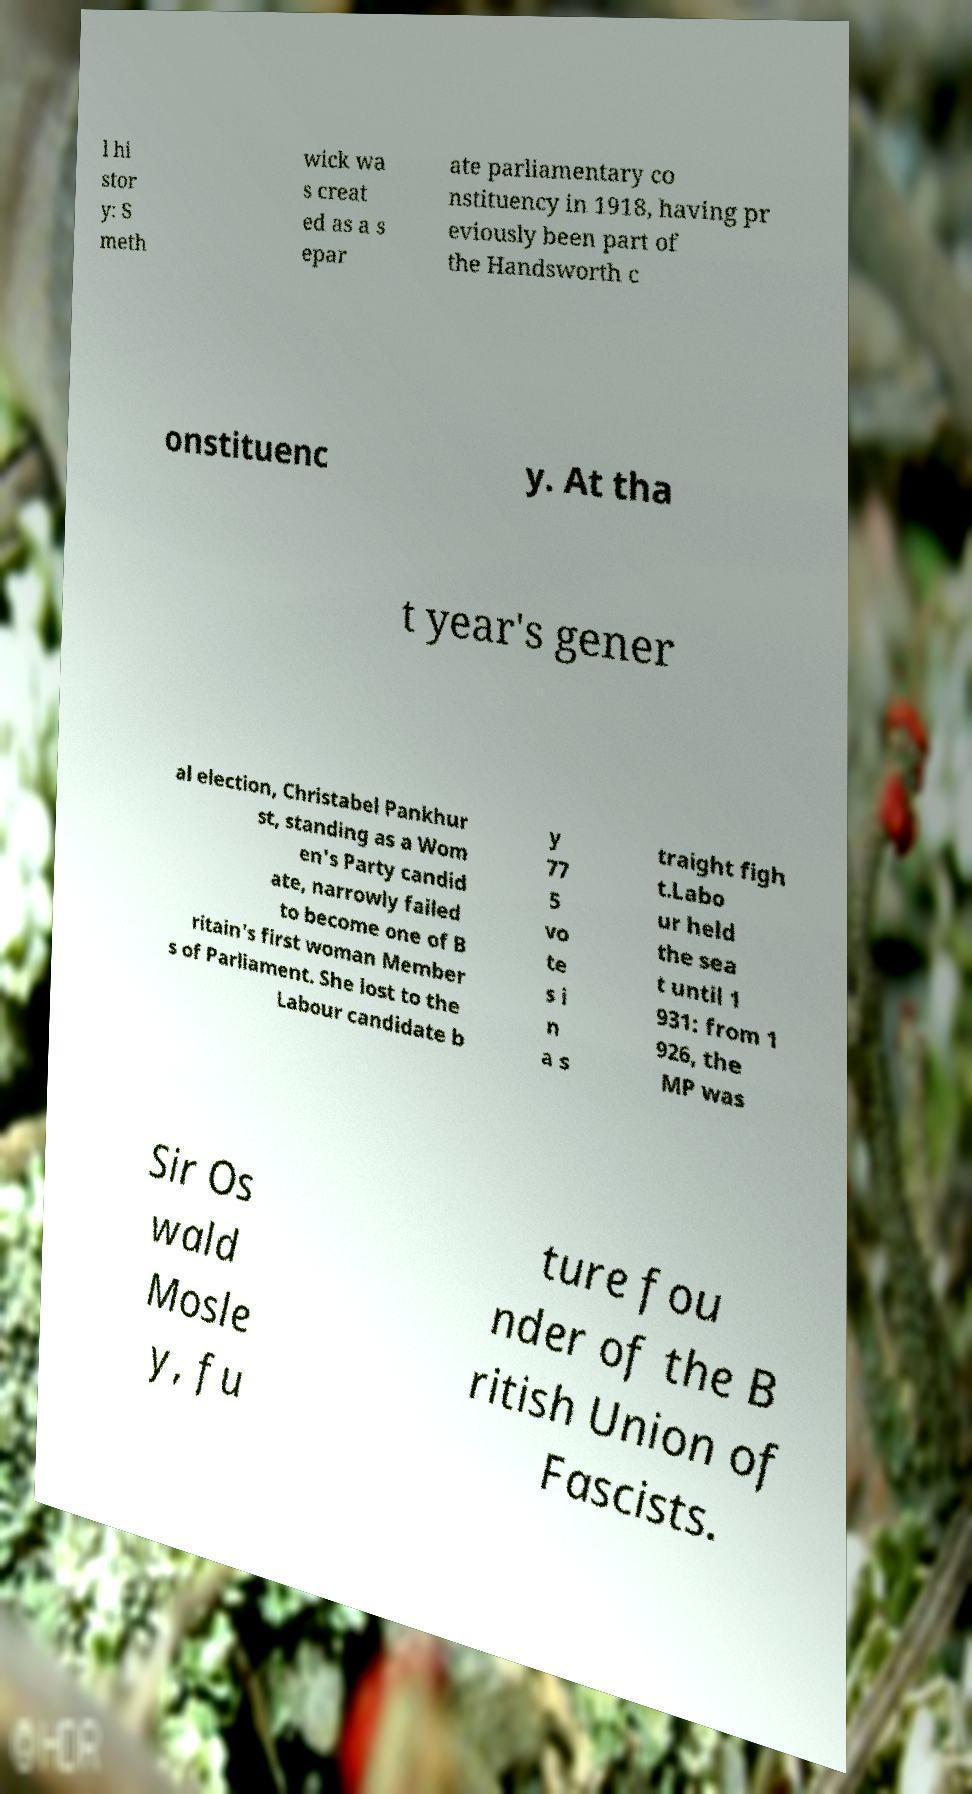Could you extract and type out the text from this image? l hi stor y: S meth wick wa s creat ed as a s epar ate parliamentary co nstituency in 1918, having pr eviously been part of the Handsworth c onstituenc y. At tha t year's gener al election, Christabel Pankhur st, standing as a Wom en's Party candid ate, narrowly failed to become one of B ritain's first woman Member s of Parliament. She lost to the Labour candidate b y 77 5 vo te s i n a s traight figh t.Labo ur held the sea t until 1 931: from 1 926, the MP was Sir Os wald Mosle y, fu ture fou nder of the B ritish Union of Fascists. 